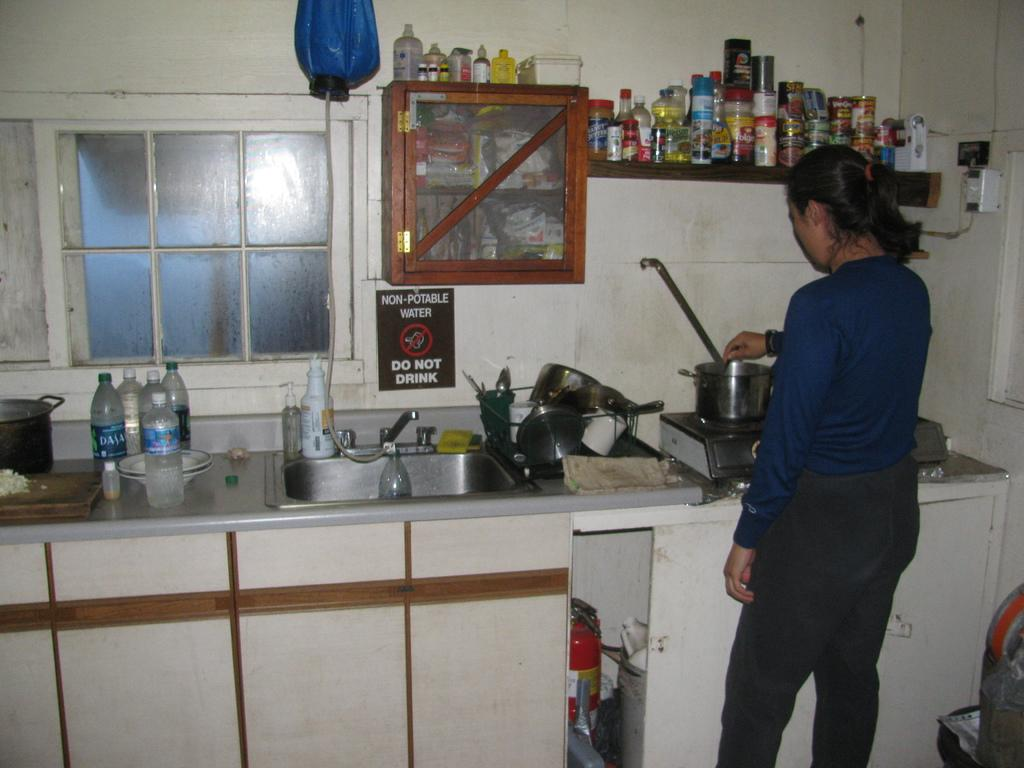<image>
Present a compact description of the photo's key features. A woman is cooking in a messy kitchen with a non-portable water sign. 